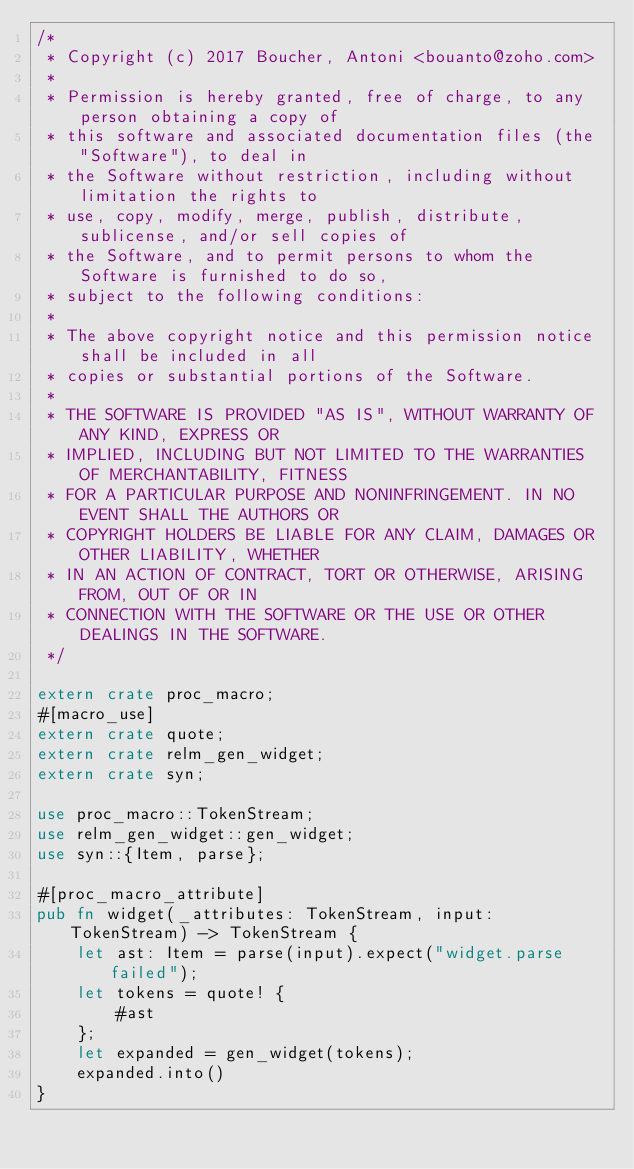Convert code to text. <code><loc_0><loc_0><loc_500><loc_500><_Rust_>/*
 * Copyright (c) 2017 Boucher, Antoni <bouanto@zoho.com>
 *
 * Permission is hereby granted, free of charge, to any person obtaining a copy of
 * this software and associated documentation files (the "Software"), to deal in
 * the Software without restriction, including without limitation the rights to
 * use, copy, modify, merge, publish, distribute, sublicense, and/or sell copies of
 * the Software, and to permit persons to whom the Software is furnished to do so,
 * subject to the following conditions:
 *
 * The above copyright notice and this permission notice shall be included in all
 * copies or substantial portions of the Software.
 *
 * THE SOFTWARE IS PROVIDED "AS IS", WITHOUT WARRANTY OF ANY KIND, EXPRESS OR
 * IMPLIED, INCLUDING BUT NOT LIMITED TO THE WARRANTIES OF MERCHANTABILITY, FITNESS
 * FOR A PARTICULAR PURPOSE AND NONINFRINGEMENT. IN NO EVENT SHALL THE AUTHORS OR
 * COPYRIGHT HOLDERS BE LIABLE FOR ANY CLAIM, DAMAGES OR OTHER LIABILITY, WHETHER
 * IN AN ACTION OF CONTRACT, TORT OR OTHERWISE, ARISING FROM, OUT OF OR IN
 * CONNECTION WITH THE SOFTWARE OR THE USE OR OTHER DEALINGS IN THE SOFTWARE.
 */

extern crate proc_macro;
#[macro_use]
extern crate quote;
extern crate relm_gen_widget;
extern crate syn;

use proc_macro::TokenStream;
use relm_gen_widget::gen_widget;
use syn::{Item, parse};

#[proc_macro_attribute]
pub fn widget(_attributes: TokenStream, input: TokenStream) -> TokenStream {
    let ast: Item = parse(input).expect("widget.parse failed");
    let tokens = quote! {
        #ast
    };
    let expanded = gen_widget(tokens);
    expanded.into()
}
</code> 